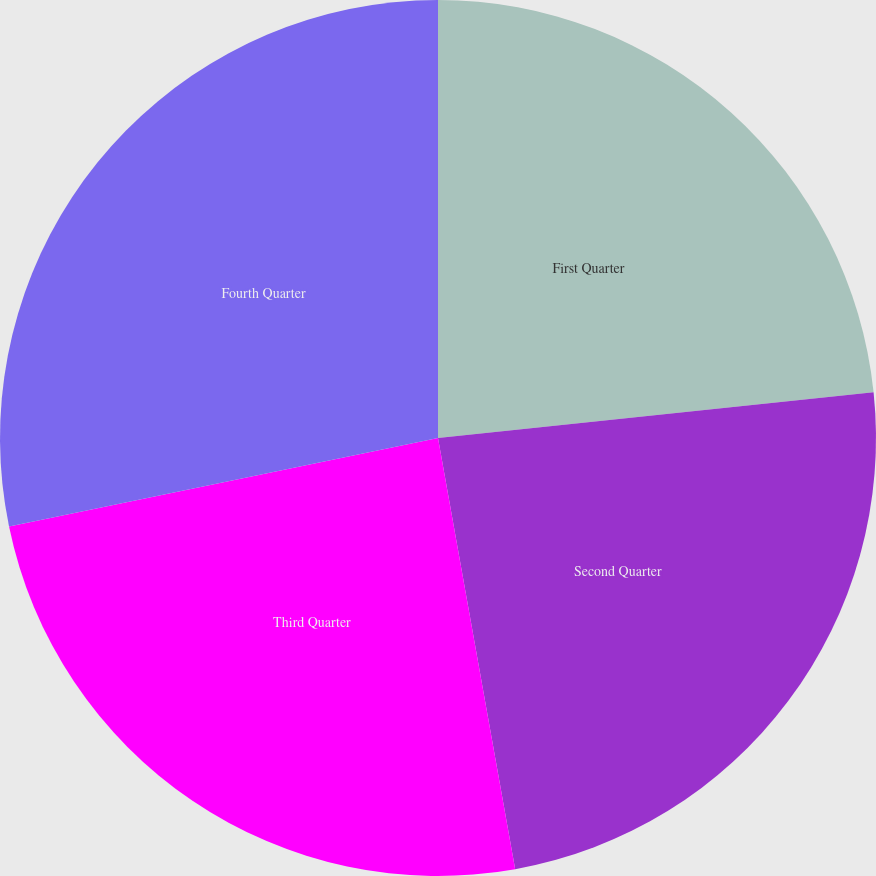Convert chart. <chart><loc_0><loc_0><loc_500><loc_500><pie_chart><fcel>First Quarter<fcel>Second Quarter<fcel>Third Quarter<fcel>Fourth Quarter<nl><fcel>23.33%<fcel>23.85%<fcel>24.58%<fcel>28.24%<nl></chart> 